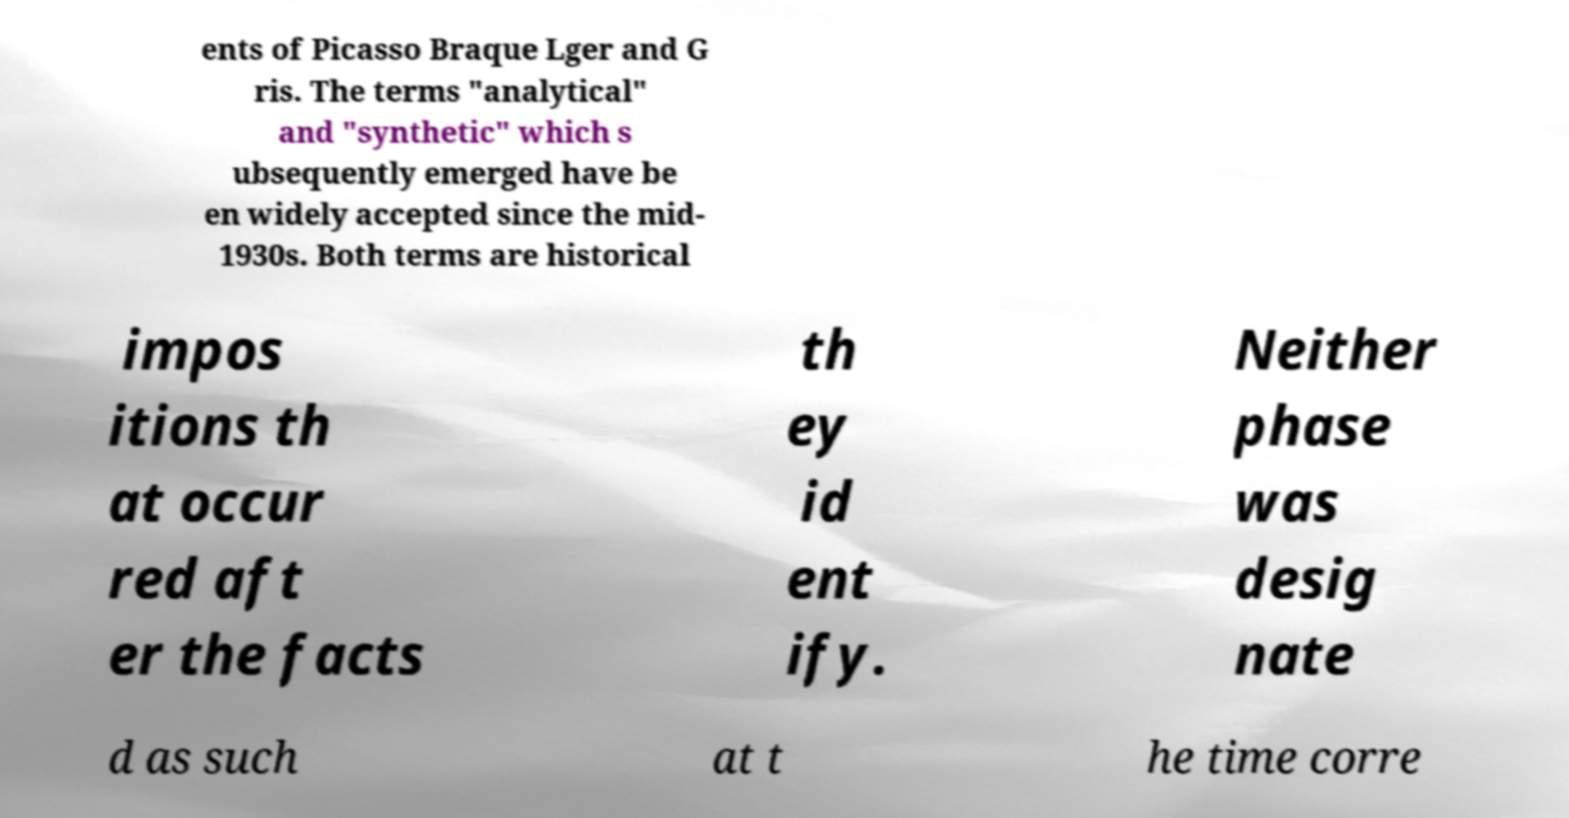Can you accurately transcribe the text from the provided image for me? ents of Picasso Braque Lger and G ris. The terms "analytical" and "synthetic" which s ubsequently emerged have be en widely accepted since the mid- 1930s. Both terms are historical impos itions th at occur red aft er the facts th ey id ent ify. Neither phase was desig nate d as such at t he time corre 